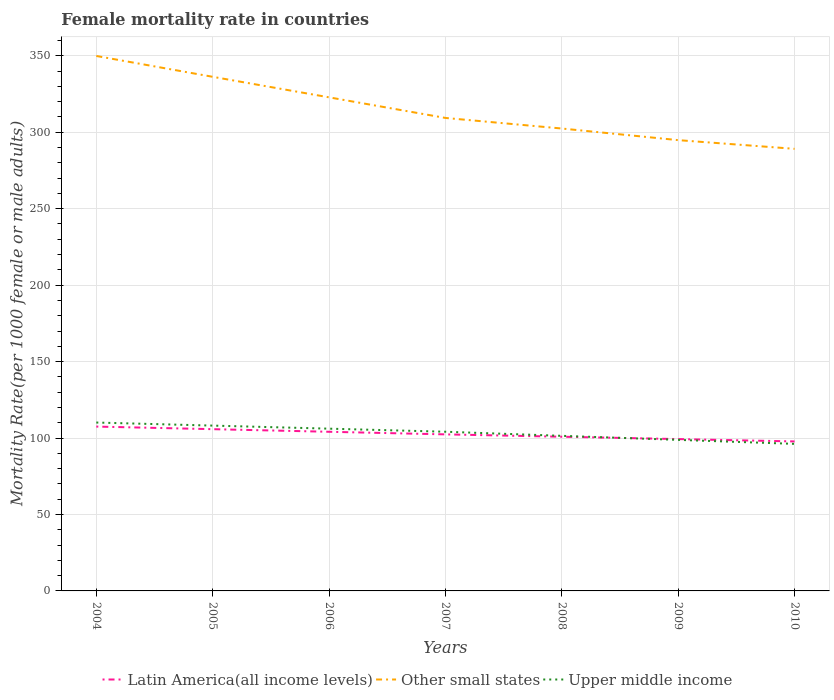How many different coloured lines are there?
Provide a short and direct response. 3. Across all years, what is the maximum female mortality rate in Other small states?
Your answer should be very brief. 289.16. What is the total female mortality rate in Upper middle income in the graph?
Offer a terse response. 2.63. What is the difference between the highest and the second highest female mortality rate in Latin America(all income levels)?
Provide a succinct answer. 9.71. What is the difference between the highest and the lowest female mortality rate in Upper middle income?
Your answer should be very brief. 4. What is the difference between two consecutive major ticks on the Y-axis?
Provide a succinct answer. 50. Are the values on the major ticks of Y-axis written in scientific E-notation?
Make the answer very short. No. Does the graph contain any zero values?
Offer a very short reply. No. How many legend labels are there?
Make the answer very short. 3. How are the legend labels stacked?
Keep it short and to the point. Horizontal. What is the title of the graph?
Your answer should be very brief. Female mortality rate in countries. Does "Cambodia" appear as one of the legend labels in the graph?
Provide a succinct answer. No. What is the label or title of the X-axis?
Ensure brevity in your answer.  Years. What is the label or title of the Y-axis?
Your response must be concise. Mortality Rate(per 1000 female or male adults). What is the Mortality Rate(per 1000 female or male adults) of Latin America(all income levels) in 2004?
Offer a very short reply. 107.49. What is the Mortality Rate(per 1000 female or male adults) in Other small states in 2004?
Make the answer very short. 349.9. What is the Mortality Rate(per 1000 female or male adults) in Upper middle income in 2004?
Provide a succinct answer. 110.14. What is the Mortality Rate(per 1000 female or male adults) of Latin America(all income levels) in 2005?
Provide a short and direct response. 105.8. What is the Mortality Rate(per 1000 female or male adults) of Other small states in 2005?
Offer a terse response. 336.28. What is the Mortality Rate(per 1000 female or male adults) of Upper middle income in 2005?
Ensure brevity in your answer.  108.13. What is the Mortality Rate(per 1000 female or male adults) in Latin America(all income levels) in 2006?
Your answer should be very brief. 104.1. What is the Mortality Rate(per 1000 female or male adults) of Other small states in 2006?
Give a very brief answer. 322.85. What is the Mortality Rate(per 1000 female or male adults) in Upper middle income in 2006?
Your answer should be compact. 106.13. What is the Mortality Rate(per 1000 female or male adults) of Latin America(all income levels) in 2007?
Provide a succinct answer. 102.39. What is the Mortality Rate(per 1000 female or male adults) in Other small states in 2007?
Your answer should be compact. 309.37. What is the Mortality Rate(per 1000 female or male adults) of Upper middle income in 2007?
Your response must be concise. 104.12. What is the Mortality Rate(per 1000 female or male adults) of Latin America(all income levels) in 2008?
Ensure brevity in your answer.  100.85. What is the Mortality Rate(per 1000 female or male adults) in Other small states in 2008?
Provide a succinct answer. 302.45. What is the Mortality Rate(per 1000 female or male adults) of Upper middle income in 2008?
Offer a terse response. 101.44. What is the Mortality Rate(per 1000 female or male adults) of Latin America(all income levels) in 2009?
Provide a succinct answer. 99.32. What is the Mortality Rate(per 1000 female or male adults) in Other small states in 2009?
Keep it short and to the point. 294.85. What is the Mortality Rate(per 1000 female or male adults) of Upper middle income in 2009?
Provide a succinct answer. 98.81. What is the Mortality Rate(per 1000 female or male adults) in Latin America(all income levels) in 2010?
Your answer should be very brief. 97.78. What is the Mortality Rate(per 1000 female or male adults) in Other small states in 2010?
Provide a short and direct response. 289.16. What is the Mortality Rate(per 1000 female or male adults) of Upper middle income in 2010?
Your response must be concise. 96.18. Across all years, what is the maximum Mortality Rate(per 1000 female or male adults) of Latin America(all income levels)?
Your answer should be very brief. 107.49. Across all years, what is the maximum Mortality Rate(per 1000 female or male adults) in Other small states?
Keep it short and to the point. 349.9. Across all years, what is the maximum Mortality Rate(per 1000 female or male adults) of Upper middle income?
Provide a short and direct response. 110.14. Across all years, what is the minimum Mortality Rate(per 1000 female or male adults) in Latin America(all income levels)?
Make the answer very short. 97.78. Across all years, what is the minimum Mortality Rate(per 1000 female or male adults) in Other small states?
Provide a short and direct response. 289.16. Across all years, what is the minimum Mortality Rate(per 1000 female or male adults) of Upper middle income?
Offer a terse response. 96.18. What is the total Mortality Rate(per 1000 female or male adults) of Latin America(all income levels) in the graph?
Give a very brief answer. 717.73. What is the total Mortality Rate(per 1000 female or male adults) in Other small states in the graph?
Provide a short and direct response. 2204.86. What is the total Mortality Rate(per 1000 female or male adults) of Upper middle income in the graph?
Give a very brief answer. 724.95. What is the difference between the Mortality Rate(per 1000 female or male adults) of Latin America(all income levels) in 2004 and that in 2005?
Make the answer very short. 1.7. What is the difference between the Mortality Rate(per 1000 female or male adults) in Other small states in 2004 and that in 2005?
Make the answer very short. 13.63. What is the difference between the Mortality Rate(per 1000 female or male adults) of Upper middle income in 2004 and that in 2005?
Offer a terse response. 2. What is the difference between the Mortality Rate(per 1000 female or male adults) in Latin America(all income levels) in 2004 and that in 2006?
Provide a succinct answer. 3.4. What is the difference between the Mortality Rate(per 1000 female or male adults) of Other small states in 2004 and that in 2006?
Ensure brevity in your answer.  27.06. What is the difference between the Mortality Rate(per 1000 female or male adults) in Upper middle income in 2004 and that in 2006?
Offer a very short reply. 4.01. What is the difference between the Mortality Rate(per 1000 female or male adults) of Latin America(all income levels) in 2004 and that in 2007?
Your response must be concise. 5.1. What is the difference between the Mortality Rate(per 1000 female or male adults) of Other small states in 2004 and that in 2007?
Your response must be concise. 40.54. What is the difference between the Mortality Rate(per 1000 female or male adults) of Upper middle income in 2004 and that in 2007?
Your answer should be compact. 6.01. What is the difference between the Mortality Rate(per 1000 female or male adults) in Latin America(all income levels) in 2004 and that in 2008?
Make the answer very short. 6.64. What is the difference between the Mortality Rate(per 1000 female or male adults) in Other small states in 2004 and that in 2008?
Ensure brevity in your answer.  47.45. What is the difference between the Mortality Rate(per 1000 female or male adults) of Upper middle income in 2004 and that in 2008?
Your answer should be compact. 8.7. What is the difference between the Mortality Rate(per 1000 female or male adults) of Latin America(all income levels) in 2004 and that in 2009?
Offer a terse response. 8.18. What is the difference between the Mortality Rate(per 1000 female or male adults) in Other small states in 2004 and that in 2009?
Keep it short and to the point. 55.05. What is the difference between the Mortality Rate(per 1000 female or male adults) in Upper middle income in 2004 and that in 2009?
Give a very brief answer. 11.33. What is the difference between the Mortality Rate(per 1000 female or male adults) in Latin America(all income levels) in 2004 and that in 2010?
Offer a very short reply. 9.71. What is the difference between the Mortality Rate(per 1000 female or male adults) in Other small states in 2004 and that in 2010?
Your answer should be very brief. 60.74. What is the difference between the Mortality Rate(per 1000 female or male adults) in Upper middle income in 2004 and that in 2010?
Provide a succinct answer. 13.96. What is the difference between the Mortality Rate(per 1000 female or male adults) of Latin America(all income levels) in 2005 and that in 2006?
Your response must be concise. 1.7. What is the difference between the Mortality Rate(per 1000 female or male adults) in Other small states in 2005 and that in 2006?
Keep it short and to the point. 13.43. What is the difference between the Mortality Rate(per 1000 female or male adults) in Upper middle income in 2005 and that in 2006?
Provide a short and direct response. 2. What is the difference between the Mortality Rate(per 1000 female or male adults) in Latin America(all income levels) in 2005 and that in 2007?
Give a very brief answer. 3.4. What is the difference between the Mortality Rate(per 1000 female or male adults) in Other small states in 2005 and that in 2007?
Your answer should be very brief. 26.91. What is the difference between the Mortality Rate(per 1000 female or male adults) of Upper middle income in 2005 and that in 2007?
Offer a very short reply. 4.01. What is the difference between the Mortality Rate(per 1000 female or male adults) in Latin America(all income levels) in 2005 and that in 2008?
Offer a terse response. 4.94. What is the difference between the Mortality Rate(per 1000 female or male adults) of Other small states in 2005 and that in 2008?
Your answer should be compact. 33.82. What is the difference between the Mortality Rate(per 1000 female or male adults) in Upper middle income in 2005 and that in 2008?
Your response must be concise. 6.69. What is the difference between the Mortality Rate(per 1000 female or male adults) in Latin America(all income levels) in 2005 and that in 2009?
Offer a very short reply. 6.48. What is the difference between the Mortality Rate(per 1000 female or male adults) of Other small states in 2005 and that in 2009?
Offer a terse response. 41.43. What is the difference between the Mortality Rate(per 1000 female or male adults) in Upper middle income in 2005 and that in 2009?
Offer a very short reply. 9.33. What is the difference between the Mortality Rate(per 1000 female or male adults) in Latin America(all income levels) in 2005 and that in 2010?
Give a very brief answer. 8.02. What is the difference between the Mortality Rate(per 1000 female or male adults) in Other small states in 2005 and that in 2010?
Ensure brevity in your answer.  47.12. What is the difference between the Mortality Rate(per 1000 female or male adults) in Upper middle income in 2005 and that in 2010?
Provide a succinct answer. 11.95. What is the difference between the Mortality Rate(per 1000 female or male adults) of Latin America(all income levels) in 2006 and that in 2007?
Provide a short and direct response. 1.7. What is the difference between the Mortality Rate(per 1000 female or male adults) of Other small states in 2006 and that in 2007?
Offer a very short reply. 13.48. What is the difference between the Mortality Rate(per 1000 female or male adults) in Upper middle income in 2006 and that in 2007?
Your response must be concise. 2.01. What is the difference between the Mortality Rate(per 1000 female or male adults) in Latin America(all income levels) in 2006 and that in 2008?
Make the answer very short. 3.24. What is the difference between the Mortality Rate(per 1000 female or male adults) of Other small states in 2006 and that in 2008?
Make the answer very short. 20.39. What is the difference between the Mortality Rate(per 1000 female or male adults) in Upper middle income in 2006 and that in 2008?
Your answer should be very brief. 4.69. What is the difference between the Mortality Rate(per 1000 female or male adults) of Latin America(all income levels) in 2006 and that in 2009?
Your response must be concise. 4.78. What is the difference between the Mortality Rate(per 1000 female or male adults) in Other small states in 2006 and that in 2009?
Your answer should be very brief. 28. What is the difference between the Mortality Rate(per 1000 female or male adults) in Upper middle income in 2006 and that in 2009?
Ensure brevity in your answer.  7.32. What is the difference between the Mortality Rate(per 1000 female or male adults) of Latin America(all income levels) in 2006 and that in 2010?
Your response must be concise. 6.32. What is the difference between the Mortality Rate(per 1000 female or male adults) in Other small states in 2006 and that in 2010?
Offer a terse response. 33.69. What is the difference between the Mortality Rate(per 1000 female or male adults) of Upper middle income in 2006 and that in 2010?
Your response must be concise. 9.95. What is the difference between the Mortality Rate(per 1000 female or male adults) in Latin America(all income levels) in 2007 and that in 2008?
Offer a very short reply. 1.54. What is the difference between the Mortality Rate(per 1000 female or male adults) in Other small states in 2007 and that in 2008?
Give a very brief answer. 6.92. What is the difference between the Mortality Rate(per 1000 female or male adults) of Upper middle income in 2007 and that in 2008?
Provide a short and direct response. 2.68. What is the difference between the Mortality Rate(per 1000 female or male adults) in Latin America(all income levels) in 2007 and that in 2009?
Your answer should be very brief. 3.08. What is the difference between the Mortality Rate(per 1000 female or male adults) of Other small states in 2007 and that in 2009?
Offer a very short reply. 14.52. What is the difference between the Mortality Rate(per 1000 female or male adults) of Upper middle income in 2007 and that in 2009?
Provide a succinct answer. 5.32. What is the difference between the Mortality Rate(per 1000 female or male adults) in Latin America(all income levels) in 2007 and that in 2010?
Provide a short and direct response. 4.61. What is the difference between the Mortality Rate(per 1000 female or male adults) in Other small states in 2007 and that in 2010?
Offer a very short reply. 20.21. What is the difference between the Mortality Rate(per 1000 female or male adults) in Upper middle income in 2007 and that in 2010?
Ensure brevity in your answer.  7.94. What is the difference between the Mortality Rate(per 1000 female or male adults) of Latin America(all income levels) in 2008 and that in 2009?
Ensure brevity in your answer.  1.54. What is the difference between the Mortality Rate(per 1000 female or male adults) of Other small states in 2008 and that in 2009?
Keep it short and to the point. 7.6. What is the difference between the Mortality Rate(per 1000 female or male adults) of Upper middle income in 2008 and that in 2009?
Provide a succinct answer. 2.63. What is the difference between the Mortality Rate(per 1000 female or male adults) of Latin America(all income levels) in 2008 and that in 2010?
Provide a short and direct response. 3.07. What is the difference between the Mortality Rate(per 1000 female or male adults) of Other small states in 2008 and that in 2010?
Provide a short and direct response. 13.29. What is the difference between the Mortality Rate(per 1000 female or male adults) in Upper middle income in 2008 and that in 2010?
Offer a very short reply. 5.26. What is the difference between the Mortality Rate(per 1000 female or male adults) in Latin America(all income levels) in 2009 and that in 2010?
Offer a very short reply. 1.54. What is the difference between the Mortality Rate(per 1000 female or male adults) in Other small states in 2009 and that in 2010?
Offer a very short reply. 5.69. What is the difference between the Mortality Rate(per 1000 female or male adults) of Upper middle income in 2009 and that in 2010?
Provide a succinct answer. 2.63. What is the difference between the Mortality Rate(per 1000 female or male adults) of Latin America(all income levels) in 2004 and the Mortality Rate(per 1000 female or male adults) of Other small states in 2005?
Provide a succinct answer. -228.78. What is the difference between the Mortality Rate(per 1000 female or male adults) of Latin America(all income levels) in 2004 and the Mortality Rate(per 1000 female or male adults) of Upper middle income in 2005?
Ensure brevity in your answer.  -0.64. What is the difference between the Mortality Rate(per 1000 female or male adults) of Other small states in 2004 and the Mortality Rate(per 1000 female or male adults) of Upper middle income in 2005?
Ensure brevity in your answer.  241.77. What is the difference between the Mortality Rate(per 1000 female or male adults) in Latin America(all income levels) in 2004 and the Mortality Rate(per 1000 female or male adults) in Other small states in 2006?
Provide a succinct answer. -215.35. What is the difference between the Mortality Rate(per 1000 female or male adults) in Latin America(all income levels) in 2004 and the Mortality Rate(per 1000 female or male adults) in Upper middle income in 2006?
Offer a terse response. 1.36. What is the difference between the Mortality Rate(per 1000 female or male adults) in Other small states in 2004 and the Mortality Rate(per 1000 female or male adults) in Upper middle income in 2006?
Your answer should be compact. 243.77. What is the difference between the Mortality Rate(per 1000 female or male adults) of Latin America(all income levels) in 2004 and the Mortality Rate(per 1000 female or male adults) of Other small states in 2007?
Your answer should be compact. -201.87. What is the difference between the Mortality Rate(per 1000 female or male adults) of Latin America(all income levels) in 2004 and the Mortality Rate(per 1000 female or male adults) of Upper middle income in 2007?
Keep it short and to the point. 3.37. What is the difference between the Mortality Rate(per 1000 female or male adults) in Other small states in 2004 and the Mortality Rate(per 1000 female or male adults) in Upper middle income in 2007?
Ensure brevity in your answer.  245.78. What is the difference between the Mortality Rate(per 1000 female or male adults) of Latin America(all income levels) in 2004 and the Mortality Rate(per 1000 female or male adults) of Other small states in 2008?
Your answer should be very brief. -194.96. What is the difference between the Mortality Rate(per 1000 female or male adults) of Latin America(all income levels) in 2004 and the Mortality Rate(per 1000 female or male adults) of Upper middle income in 2008?
Your answer should be very brief. 6.05. What is the difference between the Mortality Rate(per 1000 female or male adults) in Other small states in 2004 and the Mortality Rate(per 1000 female or male adults) in Upper middle income in 2008?
Provide a short and direct response. 248.46. What is the difference between the Mortality Rate(per 1000 female or male adults) of Latin America(all income levels) in 2004 and the Mortality Rate(per 1000 female or male adults) of Other small states in 2009?
Make the answer very short. -187.36. What is the difference between the Mortality Rate(per 1000 female or male adults) in Latin America(all income levels) in 2004 and the Mortality Rate(per 1000 female or male adults) in Upper middle income in 2009?
Your response must be concise. 8.69. What is the difference between the Mortality Rate(per 1000 female or male adults) of Other small states in 2004 and the Mortality Rate(per 1000 female or male adults) of Upper middle income in 2009?
Your response must be concise. 251.1. What is the difference between the Mortality Rate(per 1000 female or male adults) of Latin America(all income levels) in 2004 and the Mortality Rate(per 1000 female or male adults) of Other small states in 2010?
Ensure brevity in your answer.  -181.67. What is the difference between the Mortality Rate(per 1000 female or male adults) of Latin America(all income levels) in 2004 and the Mortality Rate(per 1000 female or male adults) of Upper middle income in 2010?
Make the answer very short. 11.31. What is the difference between the Mortality Rate(per 1000 female or male adults) in Other small states in 2004 and the Mortality Rate(per 1000 female or male adults) in Upper middle income in 2010?
Make the answer very short. 253.72. What is the difference between the Mortality Rate(per 1000 female or male adults) in Latin America(all income levels) in 2005 and the Mortality Rate(per 1000 female or male adults) in Other small states in 2006?
Your response must be concise. -217.05. What is the difference between the Mortality Rate(per 1000 female or male adults) of Latin America(all income levels) in 2005 and the Mortality Rate(per 1000 female or male adults) of Upper middle income in 2006?
Your response must be concise. -0.33. What is the difference between the Mortality Rate(per 1000 female or male adults) in Other small states in 2005 and the Mortality Rate(per 1000 female or male adults) in Upper middle income in 2006?
Make the answer very short. 230.15. What is the difference between the Mortality Rate(per 1000 female or male adults) of Latin America(all income levels) in 2005 and the Mortality Rate(per 1000 female or male adults) of Other small states in 2007?
Your response must be concise. -203.57. What is the difference between the Mortality Rate(per 1000 female or male adults) in Latin America(all income levels) in 2005 and the Mortality Rate(per 1000 female or male adults) in Upper middle income in 2007?
Keep it short and to the point. 1.68. What is the difference between the Mortality Rate(per 1000 female or male adults) of Other small states in 2005 and the Mortality Rate(per 1000 female or male adults) of Upper middle income in 2007?
Provide a short and direct response. 232.15. What is the difference between the Mortality Rate(per 1000 female or male adults) of Latin America(all income levels) in 2005 and the Mortality Rate(per 1000 female or male adults) of Other small states in 2008?
Your answer should be compact. -196.65. What is the difference between the Mortality Rate(per 1000 female or male adults) of Latin America(all income levels) in 2005 and the Mortality Rate(per 1000 female or male adults) of Upper middle income in 2008?
Your answer should be compact. 4.36. What is the difference between the Mortality Rate(per 1000 female or male adults) in Other small states in 2005 and the Mortality Rate(per 1000 female or male adults) in Upper middle income in 2008?
Provide a short and direct response. 234.84. What is the difference between the Mortality Rate(per 1000 female or male adults) of Latin America(all income levels) in 2005 and the Mortality Rate(per 1000 female or male adults) of Other small states in 2009?
Provide a succinct answer. -189.05. What is the difference between the Mortality Rate(per 1000 female or male adults) in Latin America(all income levels) in 2005 and the Mortality Rate(per 1000 female or male adults) in Upper middle income in 2009?
Your response must be concise. 6.99. What is the difference between the Mortality Rate(per 1000 female or male adults) of Other small states in 2005 and the Mortality Rate(per 1000 female or male adults) of Upper middle income in 2009?
Provide a succinct answer. 237.47. What is the difference between the Mortality Rate(per 1000 female or male adults) of Latin America(all income levels) in 2005 and the Mortality Rate(per 1000 female or male adults) of Other small states in 2010?
Ensure brevity in your answer.  -183.36. What is the difference between the Mortality Rate(per 1000 female or male adults) of Latin America(all income levels) in 2005 and the Mortality Rate(per 1000 female or male adults) of Upper middle income in 2010?
Offer a terse response. 9.62. What is the difference between the Mortality Rate(per 1000 female or male adults) of Other small states in 2005 and the Mortality Rate(per 1000 female or male adults) of Upper middle income in 2010?
Your response must be concise. 240.1. What is the difference between the Mortality Rate(per 1000 female or male adults) in Latin America(all income levels) in 2006 and the Mortality Rate(per 1000 female or male adults) in Other small states in 2007?
Make the answer very short. -205.27. What is the difference between the Mortality Rate(per 1000 female or male adults) of Latin America(all income levels) in 2006 and the Mortality Rate(per 1000 female or male adults) of Upper middle income in 2007?
Keep it short and to the point. -0.03. What is the difference between the Mortality Rate(per 1000 female or male adults) of Other small states in 2006 and the Mortality Rate(per 1000 female or male adults) of Upper middle income in 2007?
Your answer should be very brief. 218.72. What is the difference between the Mortality Rate(per 1000 female or male adults) in Latin America(all income levels) in 2006 and the Mortality Rate(per 1000 female or male adults) in Other small states in 2008?
Ensure brevity in your answer.  -198.36. What is the difference between the Mortality Rate(per 1000 female or male adults) in Latin America(all income levels) in 2006 and the Mortality Rate(per 1000 female or male adults) in Upper middle income in 2008?
Ensure brevity in your answer.  2.66. What is the difference between the Mortality Rate(per 1000 female or male adults) in Other small states in 2006 and the Mortality Rate(per 1000 female or male adults) in Upper middle income in 2008?
Give a very brief answer. 221.41. What is the difference between the Mortality Rate(per 1000 female or male adults) of Latin America(all income levels) in 2006 and the Mortality Rate(per 1000 female or male adults) of Other small states in 2009?
Ensure brevity in your answer.  -190.75. What is the difference between the Mortality Rate(per 1000 female or male adults) in Latin America(all income levels) in 2006 and the Mortality Rate(per 1000 female or male adults) in Upper middle income in 2009?
Make the answer very short. 5.29. What is the difference between the Mortality Rate(per 1000 female or male adults) in Other small states in 2006 and the Mortality Rate(per 1000 female or male adults) in Upper middle income in 2009?
Your answer should be very brief. 224.04. What is the difference between the Mortality Rate(per 1000 female or male adults) of Latin America(all income levels) in 2006 and the Mortality Rate(per 1000 female or male adults) of Other small states in 2010?
Make the answer very short. -185.06. What is the difference between the Mortality Rate(per 1000 female or male adults) of Latin America(all income levels) in 2006 and the Mortality Rate(per 1000 female or male adults) of Upper middle income in 2010?
Provide a short and direct response. 7.92. What is the difference between the Mortality Rate(per 1000 female or male adults) of Other small states in 2006 and the Mortality Rate(per 1000 female or male adults) of Upper middle income in 2010?
Ensure brevity in your answer.  226.67. What is the difference between the Mortality Rate(per 1000 female or male adults) of Latin America(all income levels) in 2007 and the Mortality Rate(per 1000 female or male adults) of Other small states in 2008?
Provide a short and direct response. -200.06. What is the difference between the Mortality Rate(per 1000 female or male adults) of Latin America(all income levels) in 2007 and the Mortality Rate(per 1000 female or male adults) of Upper middle income in 2008?
Your answer should be very brief. 0.95. What is the difference between the Mortality Rate(per 1000 female or male adults) of Other small states in 2007 and the Mortality Rate(per 1000 female or male adults) of Upper middle income in 2008?
Provide a short and direct response. 207.93. What is the difference between the Mortality Rate(per 1000 female or male adults) in Latin America(all income levels) in 2007 and the Mortality Rate(per 1000 female or male adults) in Other small states in 2009?
Offer a very short reply. -192.46. What is the difference between the Mortality Rate(per 1000 female or male adults) of Latin America(all income levels) in 2007 and the Mortality Rate(per 1000 female or male adults) of Upper middle income in 2009?
Keep it short and to the point. 3.59. What is the difference between the Mortality Rate(per 1000 female or male adults) in Other small states in 2007 and the Mortality Rate(per 1000 female or male adults) in Upper middle income in 2009?
Ensure brevity in your answer.  210.56. What is the difference between the Mortality Rate(per 1000 female or male adults) of Latin America(all income levels) in 2007 and the Mortality Rate(per 1000 female or male adults) of Other small states in 2010?
Your response must be concise. -186.77. What is the difference between the Mortality Rate(per 1000 female or male adults) in Latin America(all income levels) in 2007 and the Mortality Rate(per 1000 female or male adults) in Upper middle income in 2010?
Provide a short and direct response. 6.21. What is the difference between the Mortality Rate(per 1000 female or male adults) in Other small states in 2007 and the Mortality Rate(per 1000 female or male adults) in Upper middle income in 2010?
Give a very brief answer. 213.19. What is the difference between the Mortality Rate(per 1000 female or male adults) of Latin America(all income levels) in 2008 and the Mortality Rate(per 1000 female or male adults) of Other small states in 2009?
Provide a succinct answer. -194. What is the difference between the Mortality Rate(per 1000 female or male adults) of Latin America(all income levels) in 2008 and the Mortality Rate(per 1000 female or male adults) of Upper middle income in 2009?
Give a very brief answer. 2.05. What is the difference between the Mortality Rate(per 1000 female or male adults) in Other small states in 2008 and the Mortality Rate(per 1000 female or male adults) in Upper middle income in 2009?
Offer a very short reply. 203.65. What is the difference between the Mortality Rate(per 1000 female or male adults) in Latin America(all income levels) in 2008 and the Mortality Rate(per 1000 female or male adults) in Other small states in 2010?
Provide a short and direct response. -188.31. What is the difference between the Mortality Rate(per 1000 female or male adults) of Latin America(all income levels) in 2008 and the Mortality Rate(per 1000 female or male adults) of Upper middle income in 2010?
Offer a very short reply. 4.67. What is the difference between the Mortality Rate(per 1000 female or male adults) of Other small states in 2008 and the Mortality Rate(per 1000 female or male adults) of Upper middle income in 2010?
Your answer should be very brief. 206.27. What is the difference between the Mortality Rate(per 1000 female or male adults) in Latin America(all income levels) in 2009 and the Mortality Rate(per 1000 female or male adults) in Other small states in 2010?
Your response must be concise. -189.84. What is the difference between the Mortality Rate(per 1000 female or male adults) in Latin America(all income levels) in 2009 and the Mortality Rate(per 1000 female or male adults) in Upper middle income in 2010?
Your response must be concise. 3.14. What is the difference between the Mortality Rate(per 1000 female or male adults) in Other small states in 2009 and the Mortality Rate(per 1000 female or male adults) in Upper middle income in 2010?
Your response must be concise. 198.67. What is the average Mortality Rate(per 1000 female or male adults) in Latin America(all income levels) per year?
Your answer should be compact. 102.53. What is the average Mortality Rate(per 1000 female or male adults) of Other small states per year?
Provide a succinct answer. 314.98. What is the average Mortality Rate(per 1000 female or male adults) of Upper middle income per year?
Your answer should be compact. 103.56. In the year 2004, what is the difference between the Mortality Rate(per 1000 female or male adults) in Latin America(all income levels) and Mortality Rate(per 1000 female or male adults) in Other small states?
Your response must be concise. -242.41. In the year 2004, what is the difference between the Mortality Rate(per 1000 female or male adults) in Latin America(all income levels) and Mortality Rate(per 1000 female or male adults) in Upper middle income?
Your answer should be compact. -2.64. In the year 2004, what is the difference between the Mortality Rate(per 1000 female or male adults) of Other small states and Mortality Rate(per 1000 female or male adults) of Upper middle income?
Give a very brief answer. 239.77. In the year 2005, what is the difference between the Mortality Rate(per 1000 female or male adults) of Latin America(all income levels) and Mortality Rate(per 1000 female or male adults) of Other small states?
Offer a terse response. -230.48. In the year 2005, what is the difference between the Mortality Rate(per 1000 female or male adults) in Latin America(all income levels) and Mortality Rate(per 1000 female or male adults) in Upper middle income?
Your answer should be compact. -2.34. In the year 2005, what is the difference between the Mortality Rate(per 1000 female or male adults) in Other small states and Mortality Rate(per 1000 female or male adults) in Upper middle income?
Your answer should be compact. 228.14. In the year 2006, what is the difference between the Mortality Rate(per 1000 female or male adults) in Latin America(all income levels) and Mortality Rate(per 1000 female or male adults) in Other small states?
Give a very brief answer. -218.75. In the year 2006, what is the difference between the Mortality Rate(per 1000 female or male adults) in Latin America(all income levels) and Mortality Rate(per 1000 female or male adults) in Upper middle income?
Make the answer very short. -2.03. In the year 2006, what is the difference between the Mortality Rate(per 1000 female or male adults) in Other small states and Mortality Rate(per 1000 female or male adults) in Upper middle income?
Offer a terse response. 216.72. In the year 2007, what is the difference between the Mortality Rate(per 1000 female or male adults) of Latin America(all income levels) and Mortality Rate(per 1000 female or male adults) of Other small states?
Your answer should be very brief. -206.97. In the year 2007, what is the difference between the Mortality Rate(per 1000 female or male adults) in Latin America(all income levels) and Mortality Rate(per 1000 female or male adults) in Upper middle income?
Offer a very short reply. -1.73. In the year 2007, what is the difference between the Mortality Rate(per 1000 female or male adults) in Other small states and Mortality Rate(per 1000 female or male adults) in Upper middle income?
Provide a short and direct response. 205.25. In the year 2008, what is the difference between the Mortality Rate(per 1000 female or male adults) of Latin America(all income levels) and Mortality Rate(per 1000 female or male adults) of Other small states?
Give a very brief answer. -201.6. In the year 2008, what is the difference between the Mortality Rate(per 1000 female or male adults) in Latin America(all income levels) and Mortality Rate(per 1000 female or male adults) in Upper middle income?
Provide a short and direct response. -0.59. In the year 2008, what is the difference between the Mortality Rate(per 1000 female or male adults) in Other small states and Mortality Rate(per 1000 female or male adults) in Upper middle income?
Provide a short and direct response. 201.01. In the year 2009, what is the difference between the Mortality Rate(per 1000 female or male adults) in Latin America(all income levels) and Mortality Rate(per 1000 female or male adults) in Other small states?
Keep it short and to the point. -195.53. In the year 2009, what is the difference between the Mortality Rate(per 1000 female or male adults) in Latin America(all income levels) and Mortality Rate(per 1000 female or male adults) in Upper middle income?
Provide a short and direct response. 0.51. In the year 2009, what is the difference between the Mortality Rate(per 1000 female or male adults) of Other small states and Mortality Rate(per 1000 female or male adults) of Upper middle income?
Offer a terse response. 196.04. In the year 2010, what is the difference between the Mortality Rate(per 1000 female or male adults) in Latin America(all income levels) and Mortality Rate(per 1000 female or male adults) in Other small states?
Offer a very short reply. -191.38. In the year 2010, what is the difference between the Mortality Rate(per 1000 female or male adults) of Latin America(all income levels) and Mortality Rate(per 1000 female or male adults) of Upper middle income?
Your response must be concise. 1.6. In the year 2010, what is the difference between the Mortality Rate(per 1000 female or male adults) in Other small states and Mortality Rate(per 1000 female or male adults) in Upper middle income?
Give a very brief answer. 192.98. What is the ratio of the Mortality Rate(per 1000 female or male adults) of Other small states in 2004 to that in 2005?
Ensure brevity in your answer.  1.04. What is the ratio of the Mortality Rate(per 1000 female or male adults) of Upper middle income in 2004 to that in 2005?
Your answer should be compact. 1.02. What is the ratio of the Mortality Rate(per 1000 female or male adults) in Latin America(all income levels) in 2004 to that in 2006?
Give a very brief answer. 1.03. What is the ratio of the Mortality Rate(per 1000 female or male adults) of Other small states in 2004 to that in 2006?
Provide a succinct answer. 1.08. What is the ratio of the Mortality Rate(per 1000 female or male adults) in Upper middle income in 2004 to that in 2006?
Provide a succinct answer. 1.04. What is the ratio of the Mortality Rate(per 1000 female or male adults) of Latin America(all income levels) in 2004 to that in 2007?
Give a very brief answer. 1.05. What is the ratio of the Mortality Rate(per 1000 female or male adults) of Other small states in 2004 to that in 2007?
Provide a short and direct response. 1.13. What is the ratio of the Mortality Rate(per 1000 female or male adults) in Upper middle income in 2004 to that in 2007?
Give a very brief answer. 1.06. What is the ratio of the Mortality Rate(per 1000 female or male adults) in Latin America(all income levels) in 2004 to that in 2008?
Your answer should be compact. 1.07. What is the ratio of the Mortality Rate(per 1000 female or male adults) of Other small states in 2004 to that in 2008?
Your answer should be compact. 1.16. What is the ratio of the Mortality Rate(per 1000 female or male adults) of Upper middle income in 2004 to that in 2008?
Make the answer very short. 1.09. What is the ratio of the Mortality Rate(per 1000 female or male adults) in Latin America(all income levels) in 2004 to that in 2009?
Ensure brevity in your answer.  1.08. What is the ratio of the Mortality Rate(per 1000 female or male adults) of Other small states in 2004 to that in 2009?
Give a very brief answer. 1.19. What is the ratio of the Mortality Rate(per 1000 female or male adults) in Upper middle income in 2004 to that in 2009?
Ensure brevity in your answer.  1.11. What is the ratio of the Mortality Rate(per 1000 female or male adults) in Latin America(all income levels) in 2004 to that in 2010?
Offer a terse response. 1.1. What is the ratio of the Mortality Rate(per 1000 female or male adults) in Other small states in 2004 to that in 2010?
Provide a short and direct response. 1.21. What is the ratio of the Mortality Rate(per 1000 female or male adults) in Upper middle income in 2004 to that in 2010?
Provide a succinct answer. 1.15. What is the ratio of the Mortality Rate(per 1000 female or male adults) in Latin America(all income levels) in 2005 to that in 2006?
Provide a succinct answer. 1.02. What is the ratio of the Mortality Rate(per 1000 female or male adults) in Other small states in 2005 to that in 2006?
Make the answer very short. 1.04. What is the ratio of the Mortality Rate(per 1000 female or male adults) of Upper middle income in 2005 to that in 2006?
Ensure brevity in your answer.  1.02. What is the ratio of the Mortality Rate(per 1000 female or male adults) of Other small states in 2005 to that in 2007?
Ensure brevity in your answer.  1.09. What is the ratio of the Mortality Rate(per 1000 female or male adults) in Latin America(all income levels) in 2005 to that in 2008?
Offer a very short reply. 1.05. What is the ratio of the Mortality Rate(per 1000 female or male adults) in Other small states in 2005 to that in 2008?
Offer a terse response. 1.11. What is the ratio of the Mortality Rate(per 1000 female or male adults) of Upper middle income in 2005 to that in 2008?
Ensure brevity in your answer.  1.07. What is the ratio of the Mortality Rate(per 1000 female or male adults) in Latin America(all income levels) in 2005 to that in 2009?
Keep it short and to the point. 1.07. What is the ratio of the Mortality Rate(per 1000 female or male adults) in Other small states in 2005 to that in 2009?
Provide a succinct answer. 1.14. What is the ratio of the Mortality Rate(per 1000 female or male adults) of Upper middle income in 2005 to that in 2009?
Make the answer very short. 1.09. What is the ratio of the Mortality Rate(per 1000 female or male adults) in Latin America(all income levels) in 2005 to that in 2010?
Keep it short and to the point. 1.08. What is the ratio of the Mortality Rate(per 1000 female or male adults) in Other small states in 2005 to that in 2010?
Ensure brevity in your answer.  1.16. What is the ratio of the Mortality Rate(per 1000 female or male adults) in Upper middle income in 2005 to that in 2010?
Provide a short and direct response. 1.12. What is the ratio of the Mortality Rate(per 1000 female or male adults) of Latin America(all income levels) in 2006 to that in 2007?
Your answer should be very brief. 1.02. What is the ratio of the Mortality Rate(per 1000 female or male adults) in Other small states in 2006 to that in 2007?
Provide a succinct answer. 1.04. What is the ratio of the Mortality Rate(per 1000 female or male adults) in Upper middle income in 2006 to that in 2007?
Offer a very short reply. 1.02. What is the ratio of the Mortality Rate(per 1000 female or male adults) of Latin America(all income levels) in 2006 to that in 2008?
Your response must be concise. 1.03. What is the ratio of the Mortality Rate(per 1000 female or male adults) in Other small states in 2006 to that in 2008?
Keep it short and to the point. 1.07. What is the ratio of the Mortality Rate(per 1000 female or male adults) in Upper middle income in 2006 to that in 2008?
Ensure brevity in your answer.  1.05. What is the ratio of the Mortality Rate(per 1000 female or male adults) of Latin America(all income levels) in 2006 to that in 2009?
Offer a very short reply. 1.05. What is the ratio of the Mortality Rate(per 1000 female or male adults) of Other small states in 2006 to that in 2009?
Keep it short and to the point. 1.09. What is the ratio of the Mortality Rate(per 1000 female or male adults) in Upper middle income in 2006 to that in 2009?
Your answer should be compact. 1.07. What is the ratio of the Mortality Rate(per 1000 female or male adults) of Latin America(all income levels) in 2006 to that in 2010?
Provide a short and direct response. 1.06. What is the ratio of the Mortality Rate(per 1000 female or male adults) of Other small states in 2006 to that in 2010?
Your response must be concise. 1.12. What is the ratio of the Mortality Rate(per 1000 female or male adults) in Upper middle income in 2006 to that in 2010?
Keep it short and to the point. 1.1. What is the ratio of the Mortality Rate(per 1000 female or male adults) in Latin America(all income levels) in 2007 to that in 2008?
Ensure brevity in your answer.  1.02. What is the ratio of the Mortality Rate(per 1000 female or male adults) in Other small states in 2007 to that in 2008?
Offer a very short reply. 1.02. What is the ratio of the Mortality Rate(per 1000 female or male adults) in Upper middle income in 2007 to that in 2008?
Ensure brevity in your answer.  1.03. What is the ratio of the Mortality Rate(per 1000 female or male adults) in Latin America(all income levels) in 2007 to that in 2009?
Give a very brief answer. 1.03. What is the ratio of the Mortality Rate(per 1000 female or male adults) in Other small states in 2007 to that in 2009?
Your answer should be compact. 1.05. What is the ratio of the Mortality Rate(per 1000 female or male adults) of Upper middle income in 2007 to that in 2009?
Provide a short and direct response. 1.05. What is the ratio of the Mortality Rate(per 1000 female or male adults) of Latin America(all income levels) in 2007 to that in 2010?
Give a very brief answer. 1.05. What is the ratio of the Mortality Rate(per 1000 female or male adults) in Other small states in 2007 to that in 2010?
Offer a very short reply. 1.07. What is the ratio of the Mortality Rate(per 1000 female or male adults) of Upper middle income in 2007 to that in 2010?
Your response must be concise. 1.08. What is the ratio of the Mortality Rate(per 1000 female or male adults) of Latin America(all income levels) in 2008 to that in 2009?
Provide a short and direct response. 1.02. What is the ratio of the Mortality Rate(per 1000 female or male adults) in Other small states in 2008 to that in 2009?
Offer a very short reply. 1.03. What is the ratio of the Mortality Rate(per 1000 female or male adults) in Upper middle income in 2008 to that in 2009?
Provide a short and direct response. 1.03. What is the ratio of the Mortality Rate(per 1000 female or male adults) in Latin America(all income levels) in 2008 to that in 2010?
Your response must be concise. 1.03. What is the ratio of the Mortality Rate(per 1000 female or male adults) in Other small states in 2008 to that in 2010?
Keep it short and to the point. 1.05. What is the ratio of the Mortality Rate(per 1000 female or male adults) in Upper middle income in 2008 to that in 2010?
Provide a short and direct response. 1.05. What is the ratio of the Mortality Rate(per 1000 female or male adults) in Latin America(all income levels) in 2009 to that in 2010?
Provide a short and direct response. 1.02. What is the ratio of the Mortality Rate(per 1000 female or male adults) in Other small states in 2009 to that in 2010?
Ensure brevity in your answer.  1.02. What is the ratio of the Mortality Rate(per 1000 female or male adults) of Upper middle income in 2009 to that in 2010?
Provide a succinct answer. 1.03. What is the difference between the highest and the second highest Mortality Rate(per 1000 female or male adults) in Latin America(all income levels)?
Make the answer very short. 1.7. What is the difference between the highest and the second highest Mortality Rate(per 1000 female or male adults) of Other small states?
Your answer should be very brief. 13.63. What is the difference between the highest and the second highest Mortality Rate(per 1000 female or male adults) in Upper middle income?
Offer a terse response. 2. What is the difference between the highest and the lowest Mortality Rate(per 1000 female or male adults) in Latin America(all income levels)?
Your answer should be compact. 9.71. What is the difference between the highest and the lowest Mortality Rate(per 1000 female or male adults) in Other small states?
Keep it short and to the point. 60.74. What is the difference between the highest and the lowest Mortality Rate(per 1000 female or male adults) of Upper middle income?
Provide a succinct answer. 13.96. 